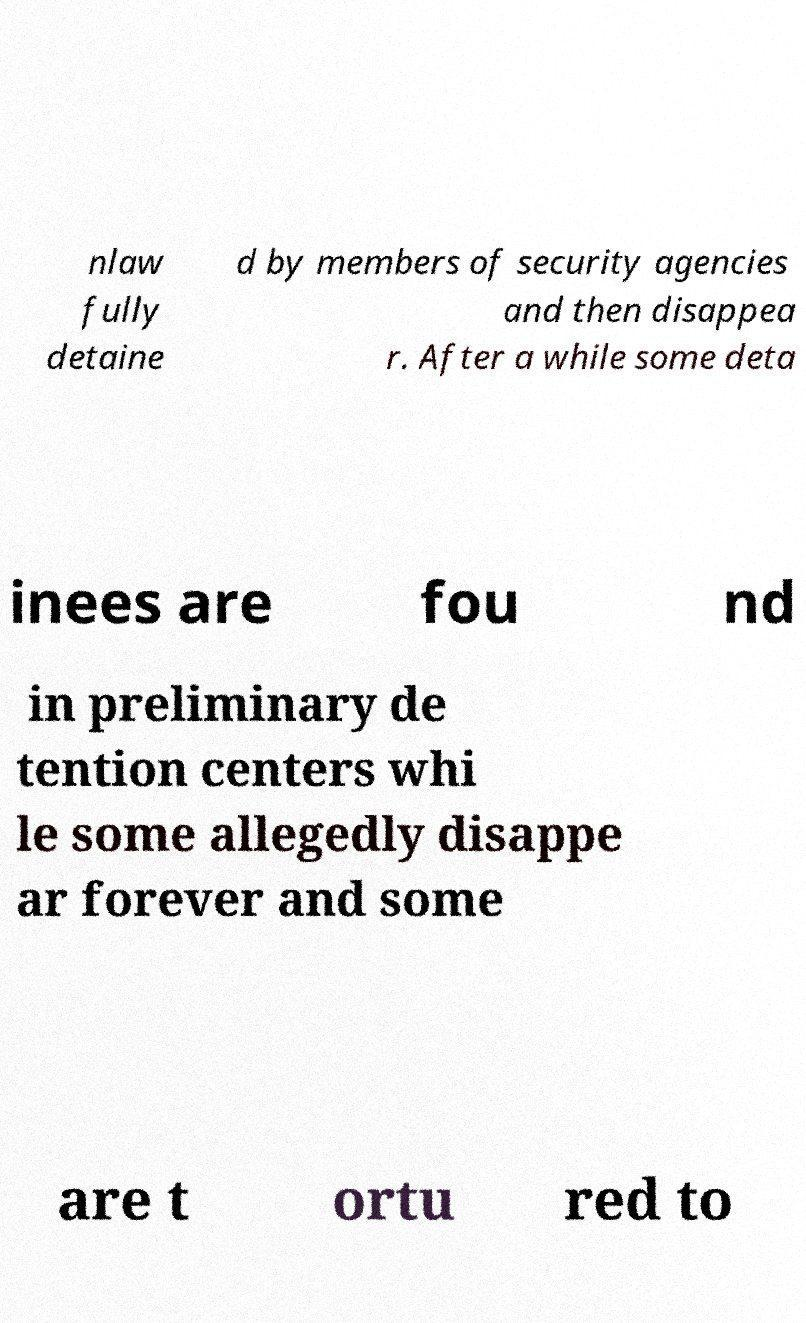For documentation purposes, I need the text within this image transcribed. Could you provide that? nlaw fully detaine d by members of security agencies and then disappea r. After a while some deta inees are fou nd in preliminary de tention centers whi le some allegedly disappe ar forever and some are t ortu red to 